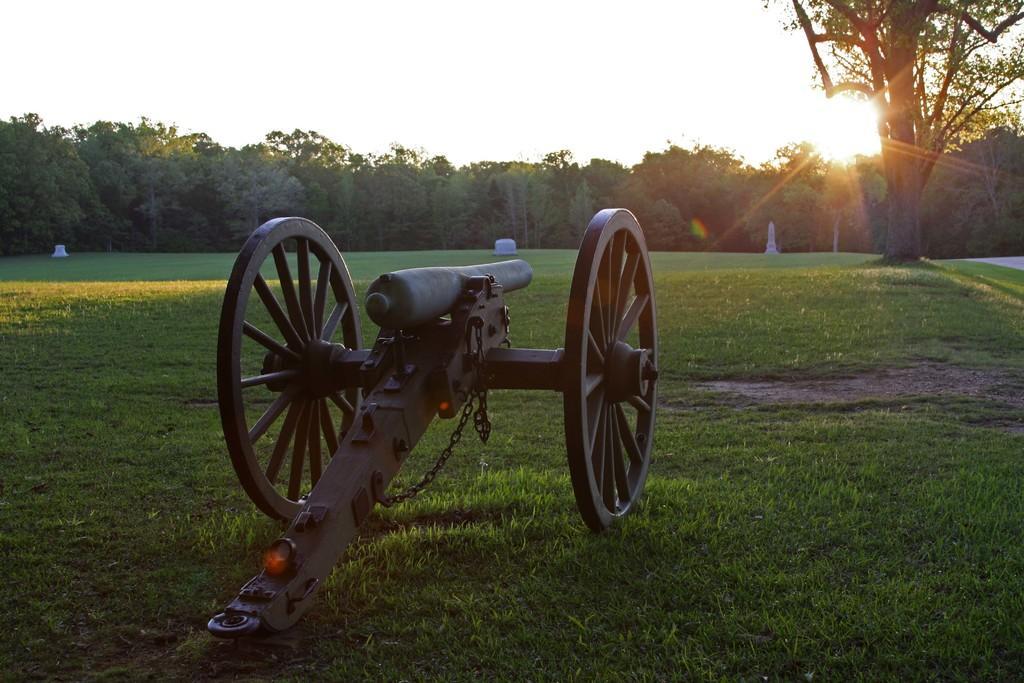Describe this image in one or two sentences. In this image there is a cannon gun on the surface of the grass, behind the Canon there are trees. 